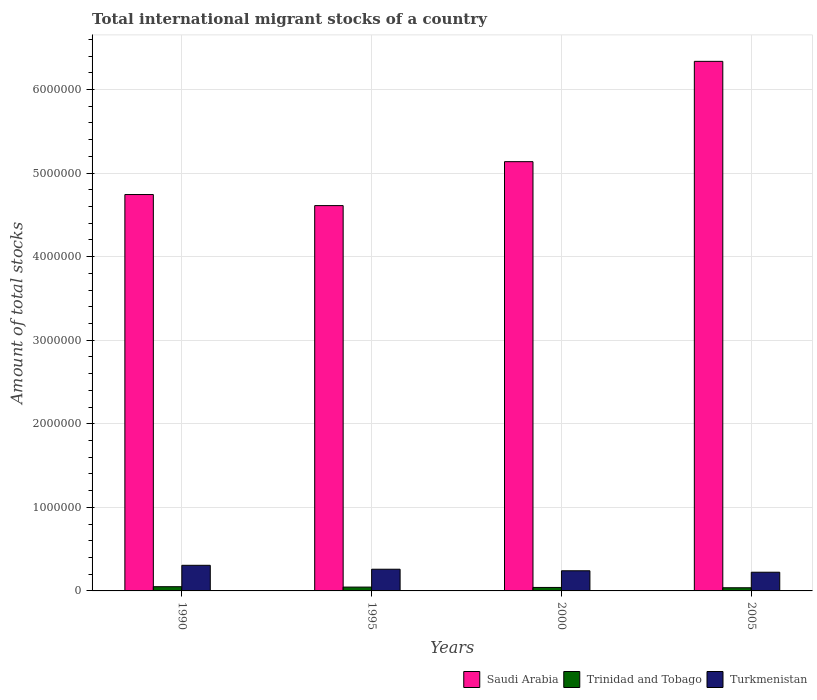Are the number of bars per tick equal to the number of legend labels?
Your answer should be compact. Yes. Are the number of bars on each tick of the X-axis equal?
Your answer should be compact. Yes. How many bars are there on the 4th tick from the right?
Your response must be concise. 3. What is the label of the 2nd group of bars from the left?
Provide a short and direct response. 1995. What is the amount of total stocks in in Saudi Arabia in 2005?
Keep it short and to the point. 6.34e+06. Across all years, what is the maximum amount of total stocks in in Trinidad and Tobago?
Make the answer very short. 5.05e+04. Across all years, what is the minimum amount of total stocks in in Turkmenistan?
Provide a succinct answer. 2.24e+05. In which year was the amount of total stocks in in Saudi Arabia maximum?
Provide a succinct answer. 2005. What is the total amount of total stocks in in Turkmenistan in the graph?
Offer a terse response. 1.03e+06. What is the difference between the amount of total stocks in in Saudi Arabia in 1990 and that in 2005?
Ensure brevity in your answer.  -1.59e+06. What is the difference between the amount of total stocks in in Trinidad and Tobago in 2005 and the amount of total stocks in in Turkmenistan in 1995?
Provide a succinct answer. -2.22e+05. What is the average amount of total stocks in in Saudi Arabia per year?
Your answer should be compact. 5.21e+06. In the year 1995, what is the difference between the amount of total stocks in in Trinidad and Tobago and amount of total stocks in in Turkmenistan?
Your response must be concise. -2.14e+05. In how many years, is the amount of total stocks in in Trinidad and Tobago greater than 3800000?
Offer a terse response. 0. What is the ratio of the amount of total stocks in in Turkmenistan in 1990 to that in 2000?
Give a very brief answer. 1.27. What is the difference between the highest and the second highest amount of total stocks in in Trinidad and Tobago?
Make the answer very short. 4640. What is the difference between the highest and the lowest amount of total stocks in in Turkmenistan?
Make the answer very short. 8.28e+04. In how many years, is the amount of total stocks in in Saudi Arabia greater than the average amount of total stocks in in Saudi Arabia taken over all years?
Offer a terse response. 1. Is the sum of the amount of total stocks in in Trinidad and Tobago in 1990 and 1995 greater than the maximum amount of total stocks in in Turkmenistan across all years?
Make the answer very short. No. What does the 3rd bar from the left in 1990 represents?
Make the answer very short. Turkmenistan. What does the 1st bar from the right in 1990 represents?
Give a very brief answer. Turkmenistan. How many bars are there?
Your answer should be very brief. 12. Are all the bars in the graph horizontal?
Ensure brevity in your answer.  No. How many years are there in the graph?
Your response must be concise. 4. What is the difference between two consecutive major ticks on the Y-axis?
Your answer should be very brief. 1.00e+06. Are the values on the major ticks of Y-axis written in scientific E-notation?
Provide a succinct answer. No. Does the graph contain grids?
Give a very brief answer. Yes. How are the legend labels stacked?
Provide a short and direct response. Horizontal. What is the title of the graph?
Ensure brevity in your answer.  Total international migrant stocks of a country. Does "Haiti" appear as one of the legend labels in the graph?
Keep it short and to the point. No. What is the label or title of the Y-axis?
Offer a terse response. Amount of total stocks. What is the Amount of total stocks in Saudi Arabia in 1990?
Your answer should be very brief. 4.74e+06. What is the Amount of total stocks of Trinidad and Tobago in 1990?
Make the answer very short. 5.05e+04. What is the Amount of total stocks in Turkmenistan in 1990?
Offer a very short reply. 3.06e+05. What is the Amount of total stocks of Saudi Arabia in 1995?
Your answer should be very brief. 4.61e+06. What is the Amount of total stocks in Trinidad and Tobago in 1995?
Your answer should be very brief. 4.59e+04. What is the Amount of total stocks of Turkmenistan in 1995?
Provide a succinct answer. 2.60e+05. What is the Amount of total stocks in Saudi Arabia in 2000?
Your answer should be compact. 5.14e+06. What is the Amount of total stocks of Trinidad and Tobago in 2000?
Provide a succinct answer. 4.16e+04. What is the Amount of total stocks in Turkmenistan in 2000?
Provide a succinct answer. 2.41e+05. What is the Amount of total stocks of Saudi Arabia in 2005?
Your answer should be compact. 6.34e+06. What is the Amount of total stocks of Trinidad and Tobago in 2005?
Offer a terse response. 3.78e+04. What is the Amount of total stocks of Turkmenistan in 2005?
Provide a succinct answer. 2.24e+05. Across all years, what is the maximum Amount of total stocks of Saudi Arabia?
Offer a terse response. 6.34e+06. Across all years, what is the maximum Amount of total stocks in Trinidad and Tobago?
Offer a terse response. 5.05e+04. Across all years, what is the maximum Amount of total stocks in Turkmenistan?
Ensure brevity in your answer.  3.06e+05. Across all years, what is the minimum Amount of total stocks of Saudi Arabia?
Offer a terse response. 4.61e+06. Across all years, what is the minimum Amount of total stocks in Trinidad and Tobago?
Make the answer very short. 3.78e+04. Across all years, what is the minimum Amount of total stocks of Turkmenistan?
Ensure brevity in your answer.  2.24e+05. What is the total Amount of total stocks of Saudi Arabia in the graph?
Provide a succinct answer. 2.08e+07. What is the total Amount of total stocks of Trinidad and Tobago in the graph?
Your answer should be very brief. 1.76e+05. What is the total Amount of total stocks in Turkmenistan in the graph?
Your answer should be very brief. 1.03e+06. What is the difference between the Amount of total stocks of Saudi Arabia in 1990 and that in 1995?
Make the answer very short. 1.32e+05. What is the difference between the Amount of total stocks of Trinidad and Tobago in 1990 and that in 1995?
Give a very brief answer. 4640. What is the difference between the Amount of total stocks of Turkmenistan in 1990 and that in 1995?
Ensure brevity in your answer.  4.69e+04. What is the difference between the Amount of total stocks in Saudi Arabia in 1990 and that in 2000?
Provide a succinct answer. -3.93e+05. What is the difference between the Amount of total stocks in Trinidad and Tobago in 1990 and that in 2000?
Keep it short and to the point. 8854. What is the difference between the Amount of total stocks of Turkmenistan in 1990 and that in 2000?
Keep it short and to the point. 6.55e+04. What is the difference between the Amount of total stocks in Saudi Arabia in 1990 and that in 2005?
Provide a short and direct response. -1.59e+06. What is the difference between the Amount of total stocks in Trinidad and Tobago in 1990 and that in 2005?
Provide a short and direct response. 1.27e+04. What is the difference between the Amount of total stocks in Turkmenistan in 1990 and that in 2005?
Provide a succinct answer. 8.28e+04. What is the difference between the Amount of total stocks in Saudi Arabia in 1995 and that in 2000?
Make the answer very short. -5.26e+05. What is the difference between the Amount of total stocks in Trinidad and Tobago in 1995 and that in 2000?
Give a very brief answer. 4214. What is the difference between the Amount of total stocks of Turkmenistan in 1995 and that in 2000?
Make the answer very short. 1.86e+04. What is the difference between the Amount of total stocks in Saudi Arabia in 1995 and that in 2005?
Your response must be concise. -1.73e+06. What is the difference between the Amount of total stocks in Trinidad and Tobago in 1995 and that in 2005?
Provide a short and direct response. 8041. What is the difference between the Amount of total stocks of Turkmenistan in 1995 and that in 2005?
Give a very brief answer. 3.59e+04. What is the difference between the Amount of total stocks in Saudi Arabia in 2000 and that in 2005?
Offer a very short reply. -1.20e+06. What is the difference between the Amount of total stocks in Trinidad and Tobago in 2000 and that in 2005?
Give a very brief answer. 3827. What is the difference between the Amount of total stocks in Turkmenistan in 2000 and that in 2005?
Provide a short and direct response. 1.73e+04. What is the difference between the Amount of total stocks in Saudi Arabia in 1990 and the Amount of total stocks in Trinidad and Tobago in 1995?
Your answer should be very brief. 4.70e+06. What is the difference between the Amount of total stocks of Saudi Arabia in 1990 and the Amount of total stocks of Turkmenistan in 1995?
Ensure brevity in your answer.  4.48e+06. What is the difference between the Amount of total stocks of Trinidad and Tobago in 1990 and the Amount of total stocks of Turkmenistan in 1995?
Make the answer very short. -2.09e+05. What is the difference between the Amount of total stocks in Saudi Arabia in 1990 and the Amount of total stocks in Trinidad and Tobago in 2000?
Ensure brevity in your answer.  4.70e+06. What is the difference between the Amount of total stocks of Saudi Arabia in 1990 and the Amount of total stocks of Turkmenistan in 2000?
Keep it short and to the point. 4.50e+06. What is the difference between the Amount of total stocks of Trinidad and Tobago in 1990 and the Amount of total stocks of Turkmenistan in 2000?
Your answer should be very brief. -1.90e+05. What is the difference between the Amount of total stocks in Saudi Arabia in 1990 and the Amount of total stocks in Trinidad and Tobago in 2005?
Offer a very short reply. 4.71e+06. What is the difference between the Amount of total stocks in Saudi Arabia in 1990 and the Amount of total stocks in Turkmenistan in 2005?
Your response must be concise. 4.52e+06. What is the difference between the Amount of total stocks of Trinidad and Tobago in 1990 and the Amount of total stocks of Turkmenistan in 2005?
Provide a succinct answer. -1.73e+05. What is the difference between the Amount of total stocks in Saudi Arabia in 1995 and the Amount of total stocks in Trinidad and Tobago in 2000?
Offer a very short reply. 4.57e+06. What is the difference between the Amount of total stocks of Saudi Arabia in 1995 and the Amount of total stocks of Turkmenistan in 2000?
Give a very brief answer. 4.37e+06. What is the difference between the Amount of total stocks of Trinidad and Tobago in 1995 and the Amount of total stocks of Turkmenistan in 2000?
Your answer should be very brief. -1.95e+05. What is the difference between the Amount of total stocks of Saudi Arabia in 1995 and the Amount of total stocks of Trinidad and Tobago in 2005?
Ensure brevity in your answer.  4.57e+06. What is the difference between the Amount of total stocks in Saudi Arabia in 1995 and the Amount of total stocks in Turkmenistan in 2005?
Offer a terse response. 4.39e+06. What is the difference between the Amount of total stocks in Trinidad and Tobago in 1995 and the Amount of total stocks in Turkmenistan in 2005?
Offer a very short reply. -1.78e+05. What is the difference between the Amount of total stocks in Saudi Arabia in 2000 and the Amount of total stocks in Trinidad and Tobago in 2005?
Your answer should be very brief. 5.10e+06. What is the difference between the Amount of total stocks in Saudi Arabia in 2000 and the Amount of total stocks in Turkmenistan in 2005?
Your answer should be compact. 4.91e+06. What is the difference between the Amount of total stocks of Trinidad and Tobago in 2000 and the Amount of total stocks of Turkmenistan in 2005?
Keep it short and to the point. -1.82e+05. What is the average Amount of total stocks of Saudi Arabia per year?
Your answer should be very brief. 5.21e+06. What is the average Amount of total stocks of Trinidad and Tobago per year?
Keep it short and to the point. 4.40e+04. What is the average Amount of total stocks of Turkmenistan per year?
Keep it short and to the point. 2.58e+05. In the year 1990, what is the difference between the Amount of total stocks of Saudi Arabia and Amount of total stocks of Trinidad and Tobago?
Your response must be concise. 4.69e+06. In the year 1990, what is the difference between the Amount of total stocks in Saudi Arabia and Amount of total stocks in Turkmenistan?
Provide a short and direct response. 4.44e+06. In the year 1990, what is the difference between the Amount of total stocks in Trinidad and Tobago and Amount of total stocks in Turkmenistan?
Your response must be concise. -2.56e+05. In the year 1995, what is the difference between the Amount of total stocks of Saudi Arabia and Amount of total stocks of Trinidad and Tobago?
Offer a terse response. 4.56e+06. In the year 1995, what is the difference between the Amount of total stocks of Saudi Arabia and Amount of total stocks of Turkmenistan?
Make the answer very short. 4.35e+06. In the year 1995, what is the difference between the Amount of total stocks in Trinidad and Tobago and Amount of total stocks in Turkmenistan?
Your response must be concise. -2.14e+05. In the year 2000, what is the difference between the Amount of total stocks of Saudi Arabia and Amount of total stocks of Trinidad and Tobago?
Ensure brevity in your answer.  5.09e+06. In the year 2000, what is the difference between the Amount of total stocks of Saudi Arabia and Amount of total stocks of Turkmenistan?
Your response must be concise. 4.90e+06. In the year 2000, what is the difference between the Amount of total stocks of Trinidad and Tobago and Amount of total stocks of Turkmenistan?
Give a very brief answer. -1.99e+05. In the year 2005, what is the difference between the Amount of total stocks in Saudi Arabia and Amount of total stocks in Trinidad and Tobago?
Make the answer very short. 6.30e+06. In the year 2005, what is the difference between the Amount of total stocks of Saudi Arabia and Amount of total stocks of Turkmenistan?
Offer a very short reply. 6.11e+06. In the year 2005, what is the difference between the Amount of total stocks in Trinidad and Tobago and Amount of total stocks in Turkmenistan?
Give a very brief answer. -1.86e+05. What is the ratio of the Amount of total stocks in Saudi Arabia in 1990 to that in 1995?
Offer a very short reply. 1.03. What is the ratio of the Amount of total stocks of Trinidad and Tobago in 1990 to that in 1995?
Provide a succinct answer. 1.1. What is the ratio of the Amount of total stocks in Turkmenistan in 1990 to that in 1995?
Your answer should be compact. 1.18. What is the ratio of the Amount of total stocks in Saudi Arabia in 1990 to that in 2000?
Your response must be concise. 0.92. What is the ratio of the Amount of total stocks of Trinidad and Tobago in 1990 to that in 2000?
Offer a very short reply. 1.21. What is the ratio of the Amount of total stocks in Turkmenistan in 1990 to that in 2000?
Provide a short and direct response. 1.27. What is the ratio of the Amount of total stocks of Saudi Arabia in 1990 to that in 2005?
Make the answer very short. 0.75. What is the ratio of the Amount of total stocks of Trinidad and Tobago in 1990 to that in 2005?
Make the answer very short. 1.34. What is the ratio of the Amount of total stocks in Turkmenistan in 1990 to that in 2005?
Ensure brevity in your answer.  1.37. What is the ratio of the Amount of total stocks in Saudi Arabia in 1995 to that in 2000?
Offer a very short reply. 0.9. What is the ratio of the Amount of total stocks of Trinidad and Tobago in 1995 to that in 2000?
Give a very brief answer. 1.1. What is the ratio of the Amount of total stocks in Turkmenistan in 1995 to that in 2000?
Your response must be concise. 1.08. What is the ratio of the Amount of total stocks of Saudi Arabia in 1995 to that in 2005?
Offer a very short reply. 0.73. What is the ratio of the Amount of total stocks in Trinidad and Tobago in 1995 to that in 2005?
Ensure brevity in your answer.  1.21. What is the ratio of the Amount of total stocks of Turkmenistan in 1995 to that in 2005?
Your answer should be very brief. 1.16. What is the ratio of the Amount of total stocks of Saudi Arabia in 2000 to that in 2005?
Your response must be concise. 0.81. What is the ratio of the Amount of total stocks of Trinidad and Tobago in 2000 to that in 2005?
Provide a short and direct response. 1.1. What is the ratio of the Amount of total stocks of Turkmenistan in 2000 to that in 2005?
Your response must be concise. 1.08. What is the difference between the highest and the second highest Amount of total stocks in Saudi Arabia?
Make the answer very short. 1.20e+06. What is the difference between the highest and the second highest Amount of total stocks in Trinidad and Tobago?
Give a very brief answer. 4640. What is the difference between the highest and the second highest Amount of total stocks of Turkmenistan?
Your answer should be very brief. 4.69e+04. What is the difference between the highest and the lowest Amount of total stocks of Saudi Arabia?
Give a very brief answer. 1.73e+06. What is the difference between the highest and the lowest Amount of total stocks in Trinidad and Tobago?
Provide a short and direct response. 1.27e+04. What is the difference between the highest and the lowest Amount of total stocks of Turkmenistan?
Give a very brief answer. 8.28e+04. 